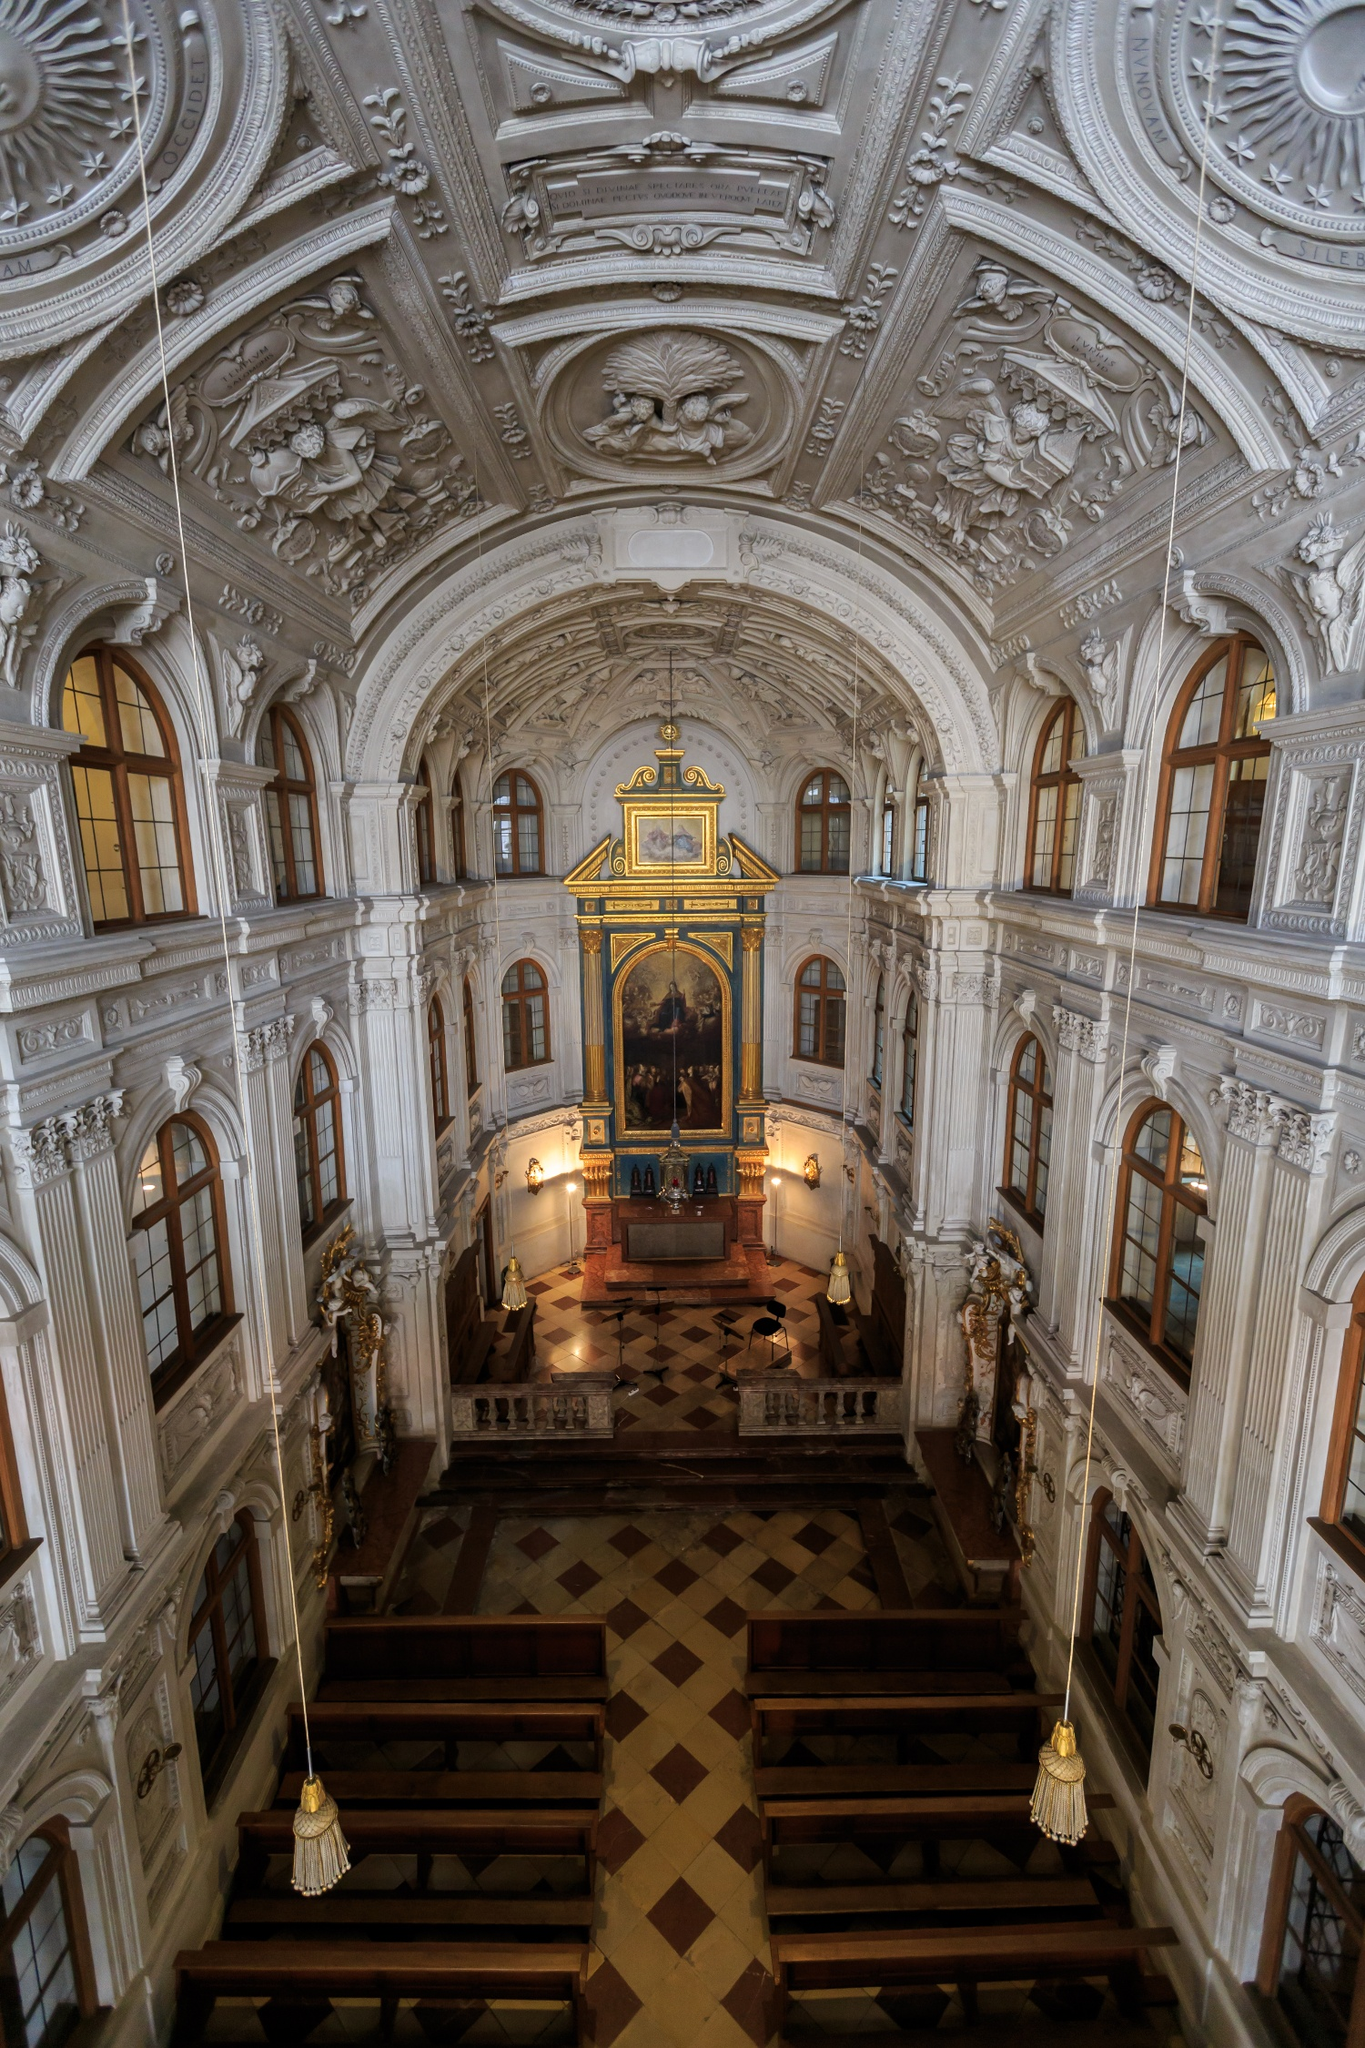What cultural or historical significance does this church hold? The Hofkirche holds immense cultural and historical significance as it is not only a place of worship but also a symbol of Dresden's rich artistic and architectural heritage. The church has witnessed many key historical events and has been a site of royal ceremonies and burials, where many members of the Wettin royal family are interred. Its stunning baroque architecture and interior artistry also make it a treasure trove of baroque art and craftsmanship, reflecting the cultural zenith of Dresden during the 18th century. 